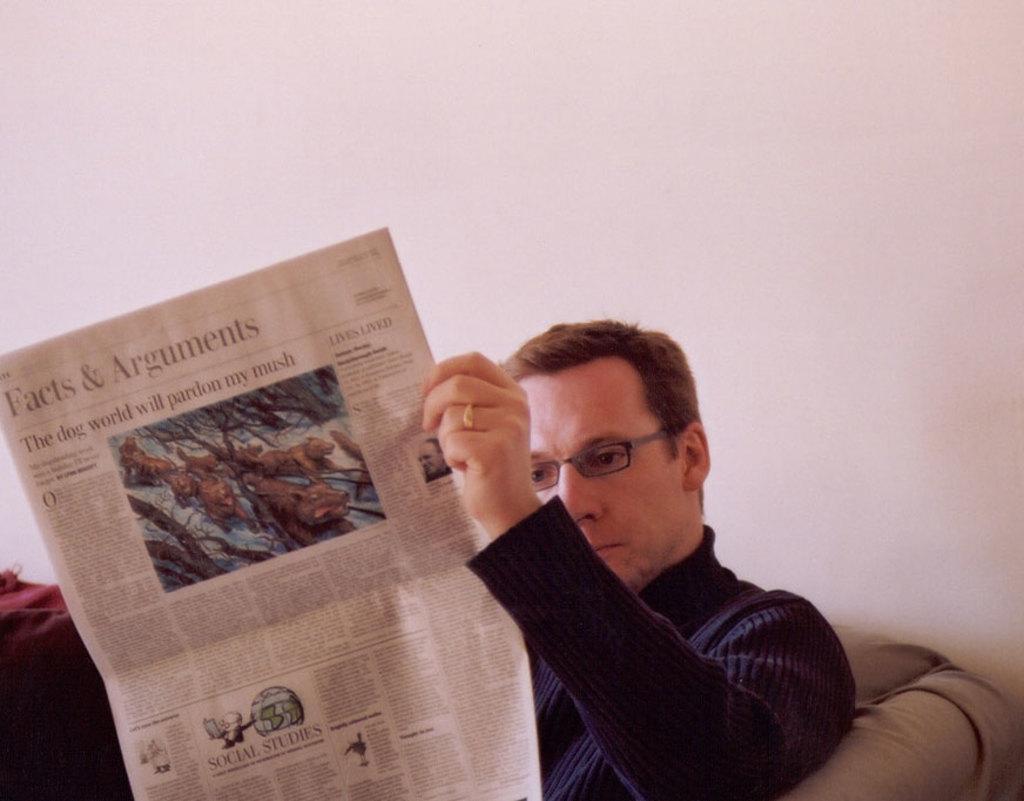In one or two sentences, can you explain what this image depicts? In this image, we can see a person holding a paper and sitting on the sofa in front of the wall. This person is wearing clothes and spectacles. 